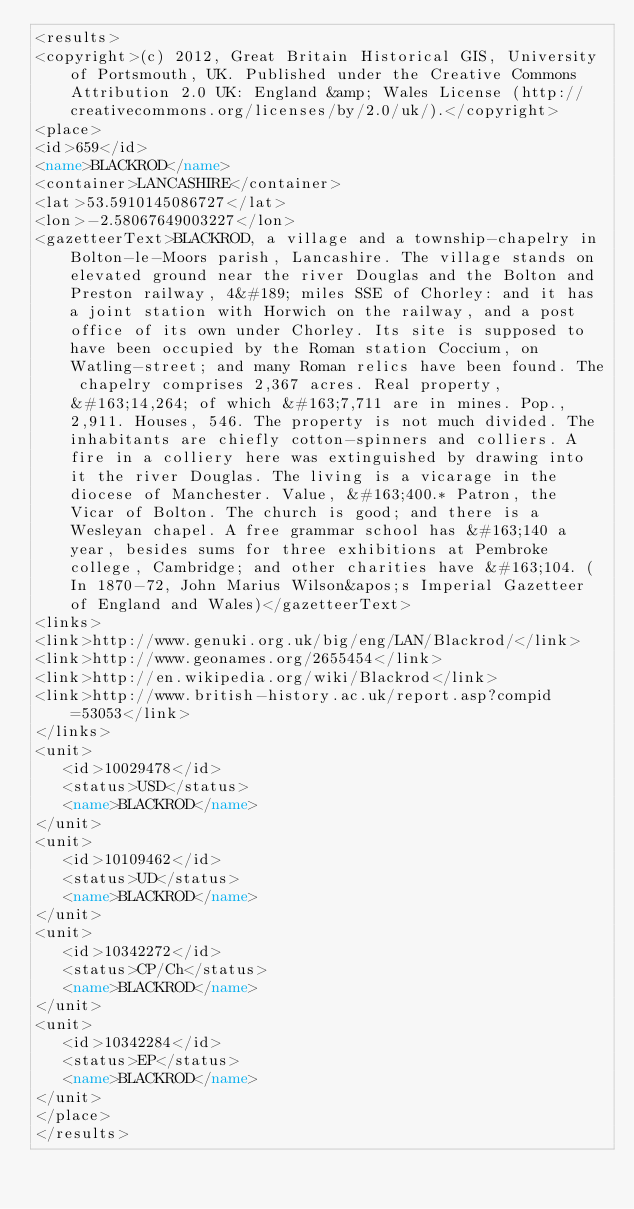<code> <loc_0><loc_0><loc_500><loc_500><_XML_><results>
<copyright>(c) 2012, Great Britain Historical GIS, University of Portsmouth, UK. Published under the Creative Commons Attribution 2.0 UK: England &amp; Wales License (http://creativecommons.org/licenses/by/2.0/uk/).</copyright>
<place>
<id>659</id>
<name>BLACKROD</name>
<container>LANCASHIRE</container>
<lat>53.5910145086727</lat>
<lon>-2.58067649003227</lon>
<gazetteerText>BLACKROD, a village and a township-chapelry in Bolton-le-Moors parish, Lancashire. The village stands on elevated ground near the river Douglas and the Bolton and Preston railway, 4&#189; miles SSE of Chorley: and it has a joint station with Horwich on the railway, and a post office of its own under Chorley. Its site is supposed to have been occupied by the Roman station Coccium, on Watling-street; and many Roman relics have been found. The chapelry comprises 2,367 acres. Real property, &#163;14,264; of which &#163;7,711 are in mines. Pop., 2,911. Houses, 546. The property is not much divided. The inhabitants are chiefly cotton-spinners and colliers. A fire in a colliery here was extinguished by drawing into it the river Douglas. The living is a vicarage in the diocese of Manchester. Value, &#163;400.* Patron, the Vicar of Bolton. The church is good; and there is a Wesleyan chapel. A free grammar school has &#163;140 a year, besides sums for three exhibitions at Pembroke college, Cambridge; and other charities have &#163;104. (In 1870-72, John Marius Wilson&apos;s Imperial Gazetteer of England and Wales)</gazetteerText>
<links>
<link>http://www.genuki.org.uk/big/eng/LAN/Blackrod/</link>
<link>http://www.geonames.org/2655454</link>
<link>http://en.wikipedia.org/wiki/Blackrod</link>
<link>http://www.british-history.ac.uk/report.asp?compid=53053</link>
</links>
<unit>
   <id>10029478</id>
   <status>USD</status>
   <name>BLACKROD</name>
</unit>
<unit>
   <id>10109462</id>
   <status>UD</status>
   <name>BLACKROD</name>
</unit>
<unit>
   <id>10342272</id>
   <status>CP/Ch</status>
   <name>BLACKROD</name>
</unit>
<unit>
   <id>10342284</id>
   <status>EP</status>
   <name>BLACKROD</name>
</unit>
</place>
</results>
</code> 